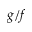Convert formula to latex. <formula><loc_0><loc_0><loc_500><loc_500>g / f</formula> 